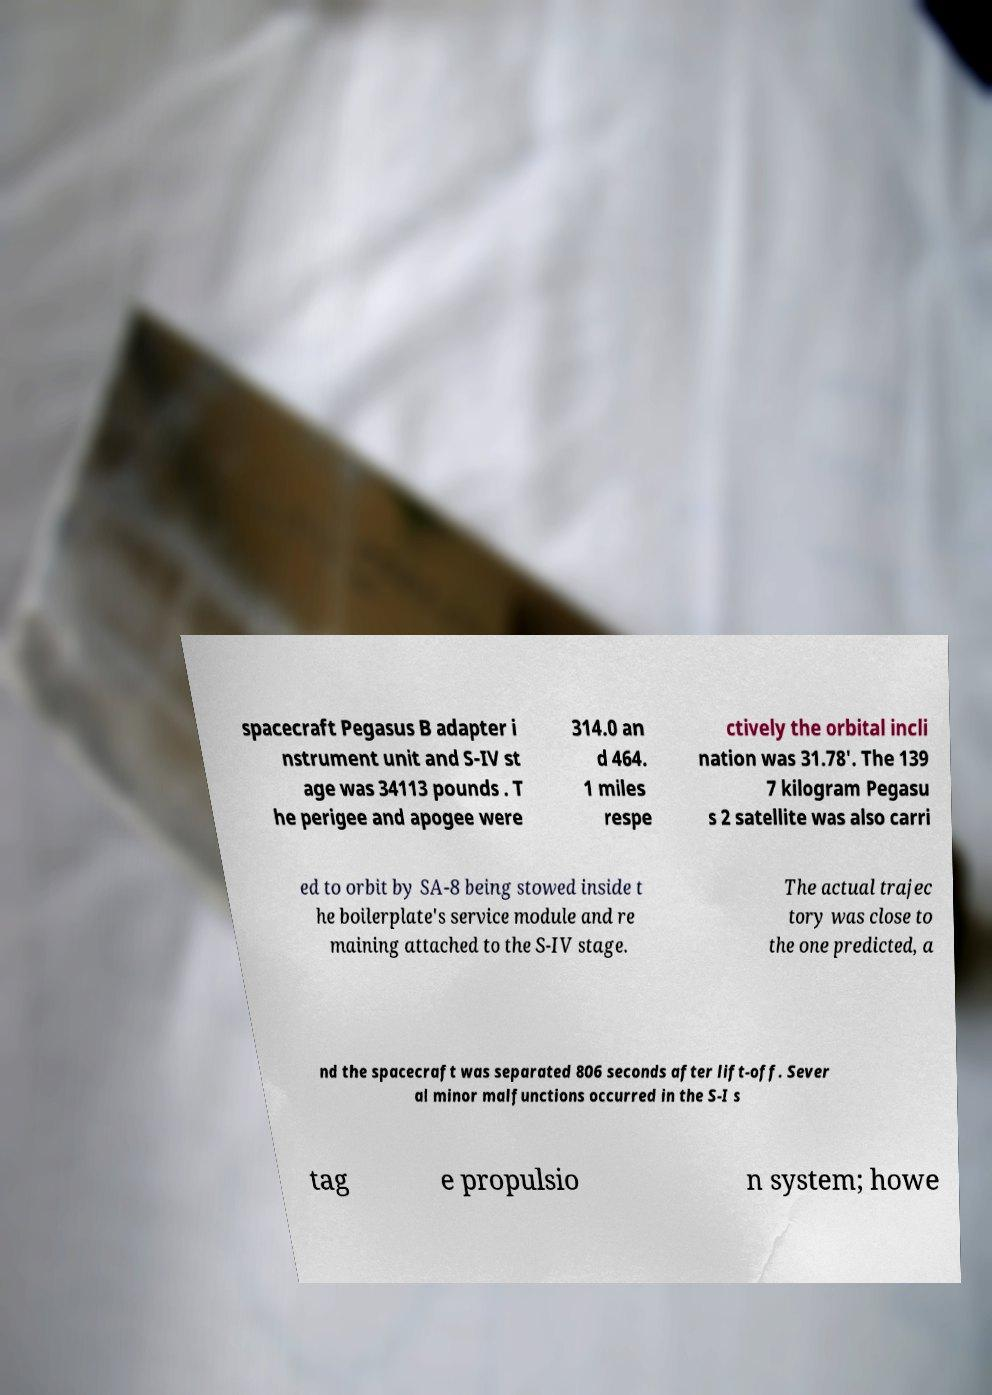For documentation purposes, I need the text within this image transcribed. Could you provide that? spacecraft Pegasus B adapter i nstrument unit and S-IV st age was 34113 pounds . T he perigee and apogee were 314.0 an d 464. 1 miles respe ctively the orbital incli nation was 31.78'. The 139 7 kilogram Pegasu s 2 satellite was also carri ed to orbit by SA-8 being stowed inside t he boilerplate's service module and re maining attached to the S-IV stage. The actual trajec tory was close to the one predicted, a nd the spacecraft was separated 806 seconds after lift-off. Sever al minor malfunctions occurred in the S-I s tag e propulsio n system; howe 